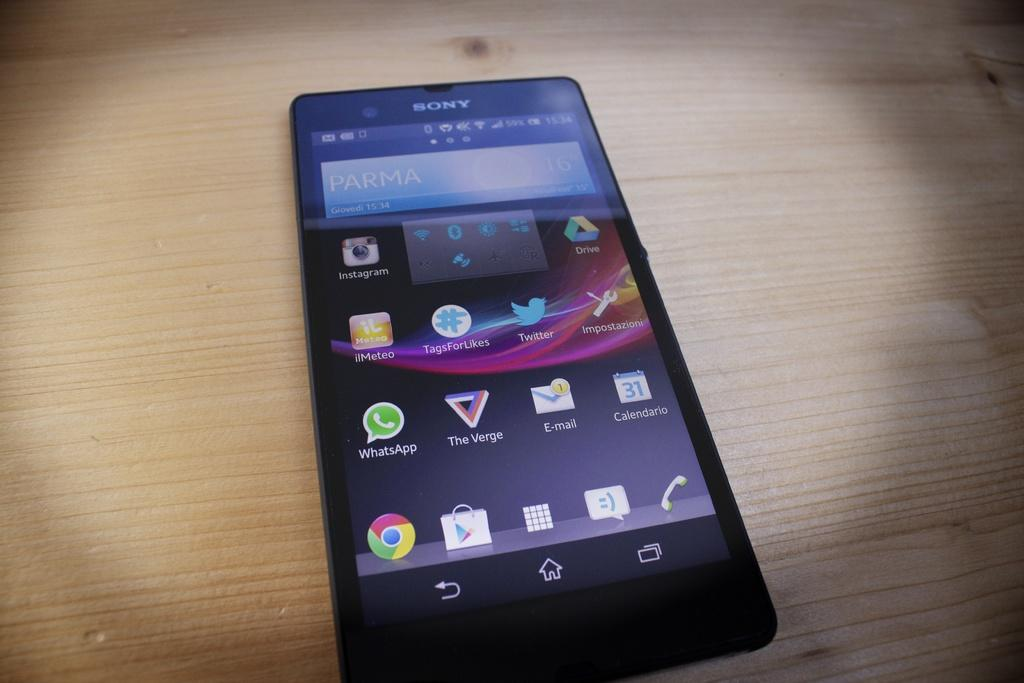Provide a one-sentence caption for the provided image. a black sony phone that says 'parma' on the screen. 